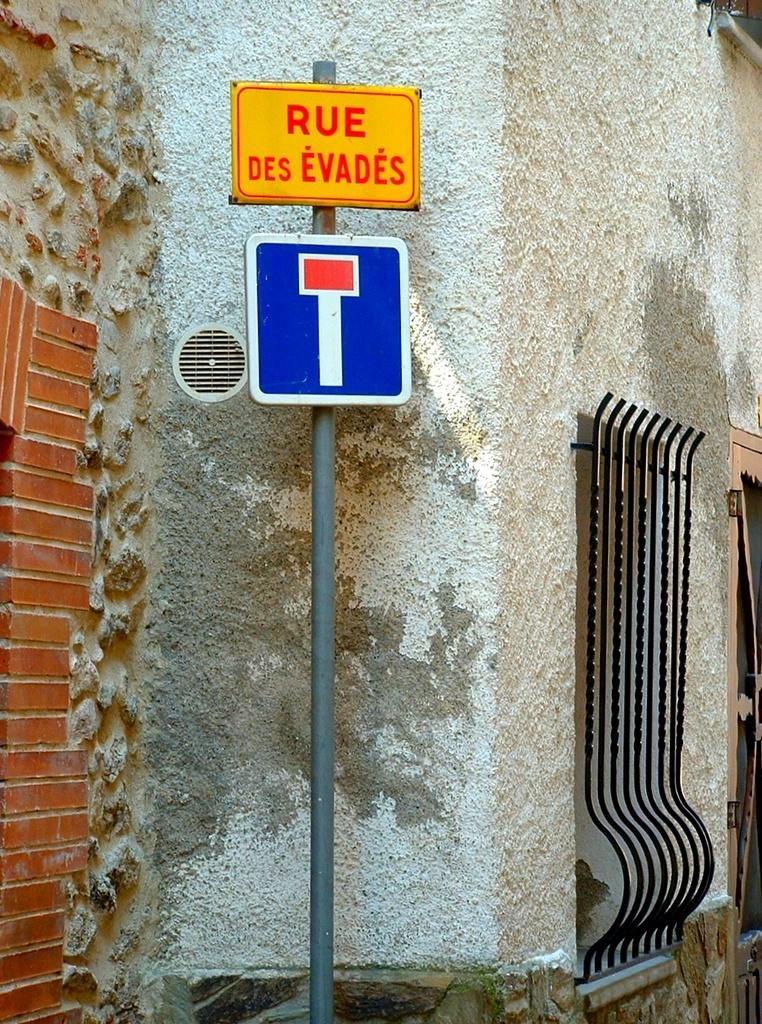<image>
Provide a brief description of the given image. Above a blue sign is a yellow sign that reads "rue des evades." 